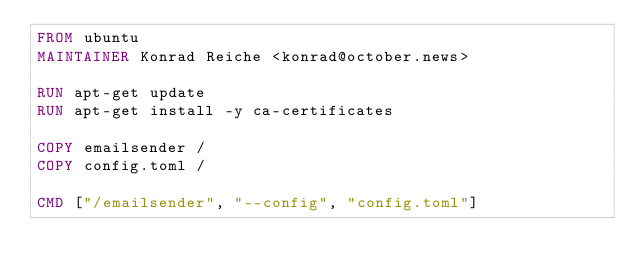<code> <loc_0><loc_0><loc_500><loc_500><_Dockerfile_>FROM ubuntu
MAINTAINER Konrad Reiche <konrad@october.news>

RUN apt-get update
RUN apt-get install -y ca-certificates

COPY emailsender /
COPY config.toml /

CMD ["/emailsender", "--config", "config.toml"]
</code> 